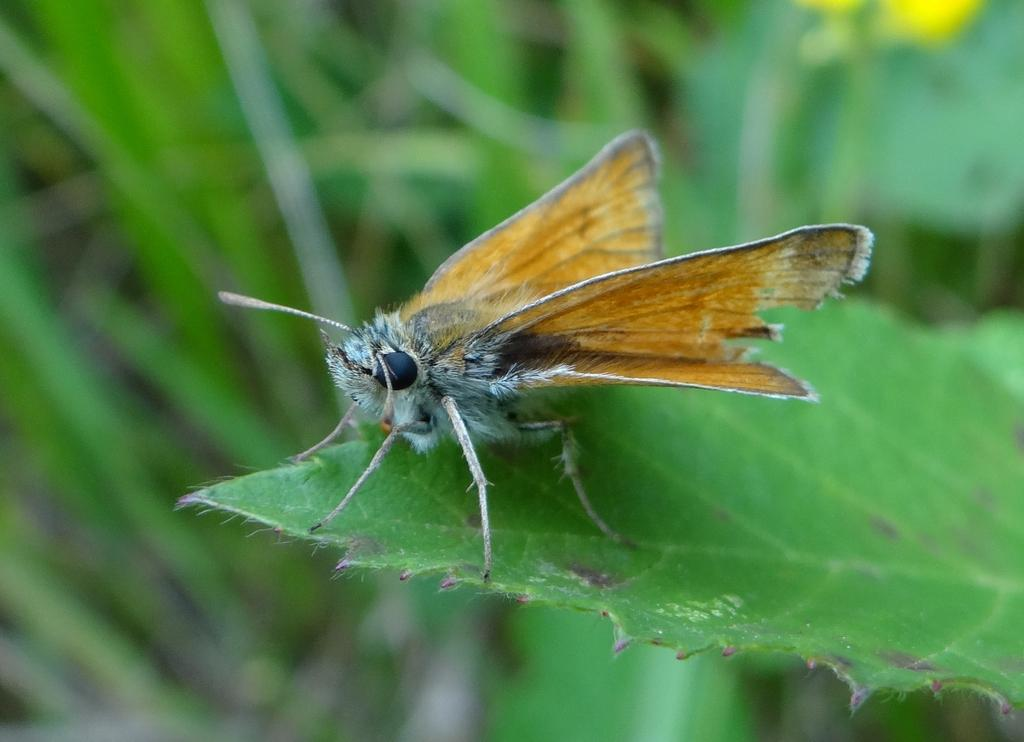What is the main subject in the foreground of the picture? There is an insect in the foreground of the picture. Where is the insect located? The insect is on a leaf. What can be seen in the background of the image? There is greenery in the background of the image. Reasoning: Let's think step by following the guidelines to produce the conversation. We start by identifying the main subject in the image, which is the insect. Then, we describe the insect's location, which is on a leaf. Finally, we mention the background of the image, which consists of greenery. Each question is designed to elicit a specific detail about the image that is known from the provided facts. Absurd Question/Answer: What type of pollution can be seen in the image? There is no pollution visible in the image; it features an insect on a leaf with greenery in the background. 